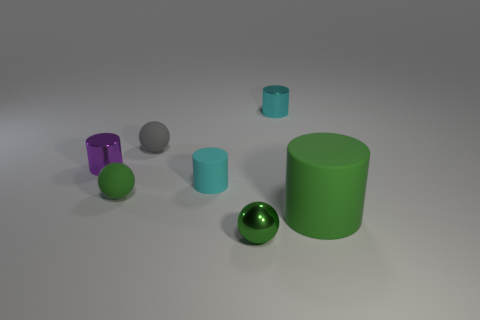Are there any matte cylinders?
Your answer should be very brief. Yes. Are there any other things that have the same material as the gray thing?
Make the answer very short. Yes. Is there a large purple block made of the same material as the gray sphere?
Offer a very short reply. No. There is another cyan object that is the same size as the cyan matte object; what is its material?
Your response must be concise. Metal. What number of small purple things have the same shape as the big object?
Make the answer very short. 1. There is a gray object that is the same material as the big green thing; what is its size?
Offer a very short reply. Small. There is a tiny thing that is both in front of the small cyan rubber object and to the right of the small gray rubber ball; what is it made of?
Ensure brevity in your answer.  Metal. How many cylinders have the same size as the gray rubber ball?
Make the answer very short. 3. What material is the green object that is the same shape as the purple metallic thing?
Give a very brief answer. Rubber. What number of things are either cylinders behind the tiny gray ball or things on the left side of the metal ball?
Provide a succinct answer. 5. 